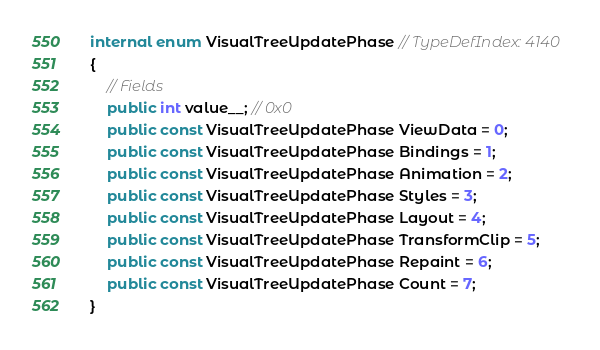<code> <loc_0><loc_0><loc_500><loc_500><_C#_>internal enum VisualTreeUpdatePhase // TypeDefIndex: 4140
{
	// Fields
	public int value__; // 0x0
	public const VisualTreeUpdatePhase ViewData = 0;
	public const VisualTreeUpdatePhase Bindings = 1;
	public const VisualTreeUpdatePhase Animation = 2;
	public const VisualTreeUpdatePhase Styles = 3;
	public const VisualTreeUpdatePhase Layout = 4;
	public const VisualTreeUpdatePhase TransformClip = 5;
	public const VisualTreeUpdatePhase Repaint = 6;
	public const VisualTreeUpdatePhase Count = 7;
}

</code> 